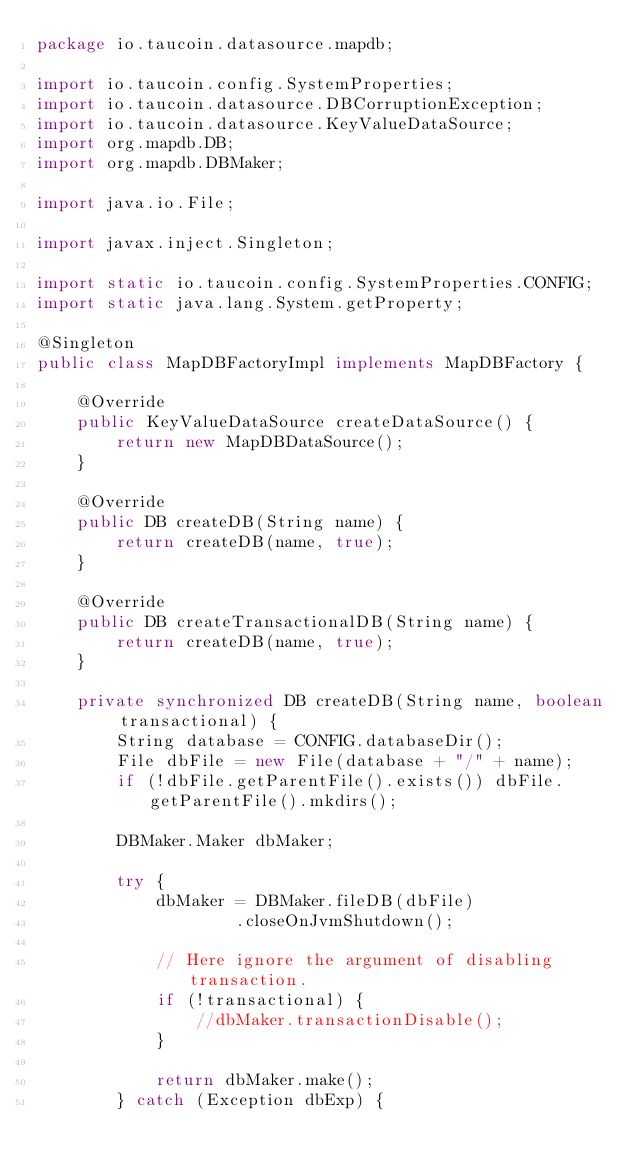Convert code to text. <code><loc_0><loc_0><loc_500><loc_500><_Java_>package io.taucoin.datasource.mapdb;

import io.taucoin.config.SystemProperties;
import io.taucoin.datasource.DBCorruptionException;
import io.taucoin.datasource.KeyValueDataSource;
import org.mapdb.DB;
import org.mapdb.DBMaker;

import java.io.File;

import javax.inject.Singleton;

import static io.taucoin.config.SystemProperties.CONFIG;
import static java.lang.System.getProperty;

@Singleton
public class MapDBFactoryImpl implements MapDBFactory {

    @Override
    public KeyValueDataSource createDataSource() {
        return new MapDBDataSource();
    }

    @Override
    public DB createDB(String name) {
        return createDB(name, true);
    }

    @Override
    public DB createTransactionalDB(String name) {
        return createDB(name, true);
    }

    private synchronized DB createDB(String name, boolean transactional) {
        String database = CONFIG.databaseDir();
        File dbFile = new File(database + "/" + name);
        if (!dbFile.getParentFile().exists()) dbFile.getParentFile().mkdirs();

        DBMaker.Maker dbMaker;

        try {
            dbMaker = DBMaker.fileDB(dbFile)
                    .closeOnJvmShutdown();

            // Here ignore the argument of disabling transaction.
            if (!transactional) {
                //dbMaker.transactionDisable();
            }

            return dbMaker.make();
        } catch (Exception dbExp) {</code> 